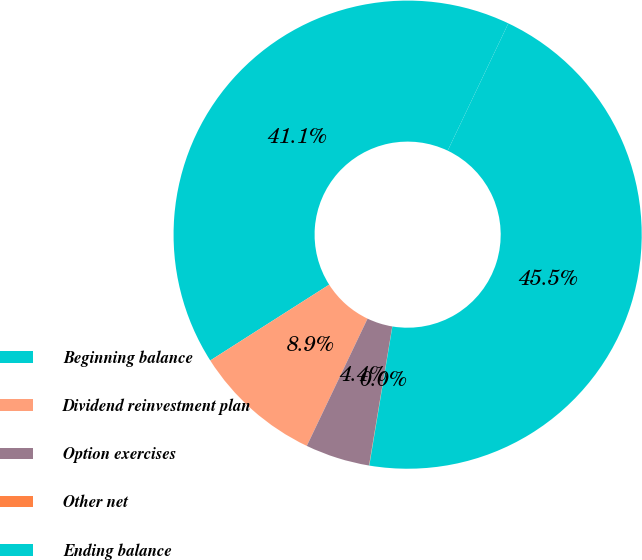Convert chart to OTSL. <chart><loc_0><loc_0><loc_500><loc_500><pie_chart><fcel>Beginning balance<fcel>Dividend reinvestment plan<fcel>Option exercises<fcel>Other net<fcel>Ending balance<nl><fcel>41.11%<fcel>8.88%<fcel>4.45%<fcel>0.02%<fcel>45.54%<nl></chart> 